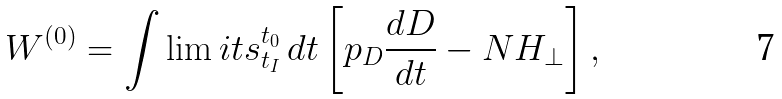<formula> <loc_0><loc_0><loc_500><loc_500>W ^ { ( 0 ) } = \int \lim i t s _ { t _ { I } } ^ { t _ { 0 } } \, d t \left [ p _ { D } \frac { d D } { d t } - N H _ { \bot } \right ] ,</formula> 